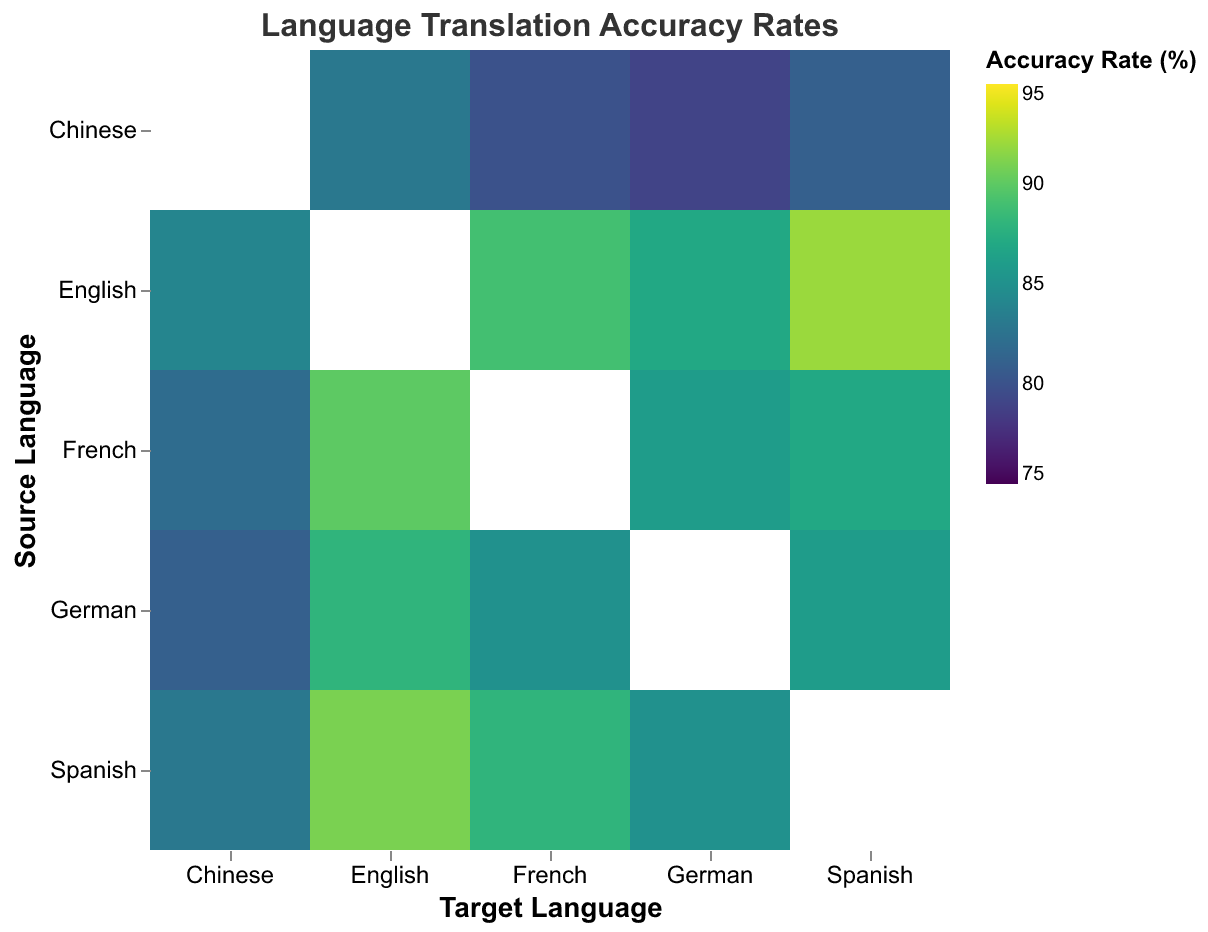What is the title of the heatmap? The title of the heatmap is displayed prominently at the top of the figure in larger font size. It summarizes the overall content of the heatmap.
Answer: Language Translation Accuracy Rates Which language pair has the highest translation accuracy rate? The heatmap uses a color scale to represent accuracy rates, where a higher rate typically corresponds to a specific color or intensity. The highest value corresponds to the brightest or most intense color.
Answer: English to Spanish Which translation direction has the lowest accuracy rate? The heatmap shows various source and target language pairs. By identifying the pair with the lowest color intensity (least bright or least intense color), we can determine the lowest accuracy rate.
Answer: Chinese to German Is there a noticeable difference in accuracy rates when translating from English to other languages compared to translating from Chinese to other languages? Comparing the colors for translations from English and from Chinese to various target languages, English generally has stronger or brighter colors, indicating higher accuracy rates overall.
Answer: Yes, English to others generally has higher accuracy How does the accuracy rate of translating from Spanish to English compare to translating from German to English? By locating the cell for Spanish to English and the cell for German to English in the heatmap, we can compare the color intensities or specific numeric values.
Answer: Spanish to English is higher Which source language generally results in the highest translation accuracy rates across different target languages? By visually scanning the heatmap row-wise for each source language and comparing the overall brightness or intensity of colors, the source language with the highest average intensity can be identified.
Answer: English What's the average accuracy rate for translations involving French as the target language? Identify all cells where French is the target language and calculate their mean value. The cells to consider are English to French, Spanish to French, German to French, and Chinese to French. (89 + 88 + 86 + 80) / 4 = 85.75
Answer: 85.75 Does translating between English and French have similar accuracy rates in both directions? Compare the color intensities and exact numeric values for English to French and French to English in the heatmap. Both values are close, showing a small difference. (89 and 90)
Answer: Yes, they are similar Which translation direction has more than 85% and less than 90% accuracy rate? Look for cells with the numeric values between 85% and 90% and identify their source and target language pairs. Spanish to French (88%), Spanish to German (85%), French to German (86%), German to English (88%), German to Spanish (86%), French to Spanish (87%)
Answer: Multiple pairs: Spanish to French, Spanish to German, French to German, German to English, among others 